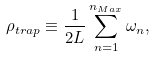Convert formula to latex. <formula><loc_0><loc_0><loc_500><loc_500>\rho _ { t r a p } \equiv \frac { 1 } { 2 L } \sum _ { n = 1 } ^ { n _ { M a x } } \omega _ { n } ,</formula> 